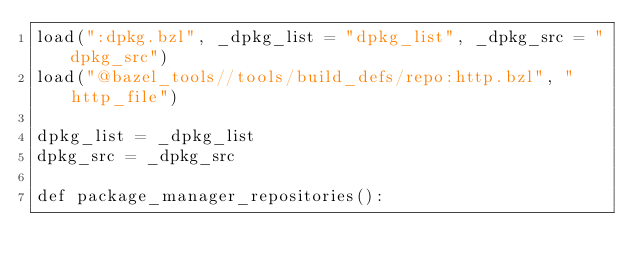<code> <loc_0><loc_0><loc_500><loc_500><_Python_>load(":dpkg.bzl", _dpkg_list = "dpkg_list", _dpkg_src = "dpkg_src")
load("@bazel_tools//tools/build_defs/repo:http.bzl", "http_file")

dpkg_list = _dpkg_list
dpkg_src = _dpkg_src

def package_manager_repositories():</code> 